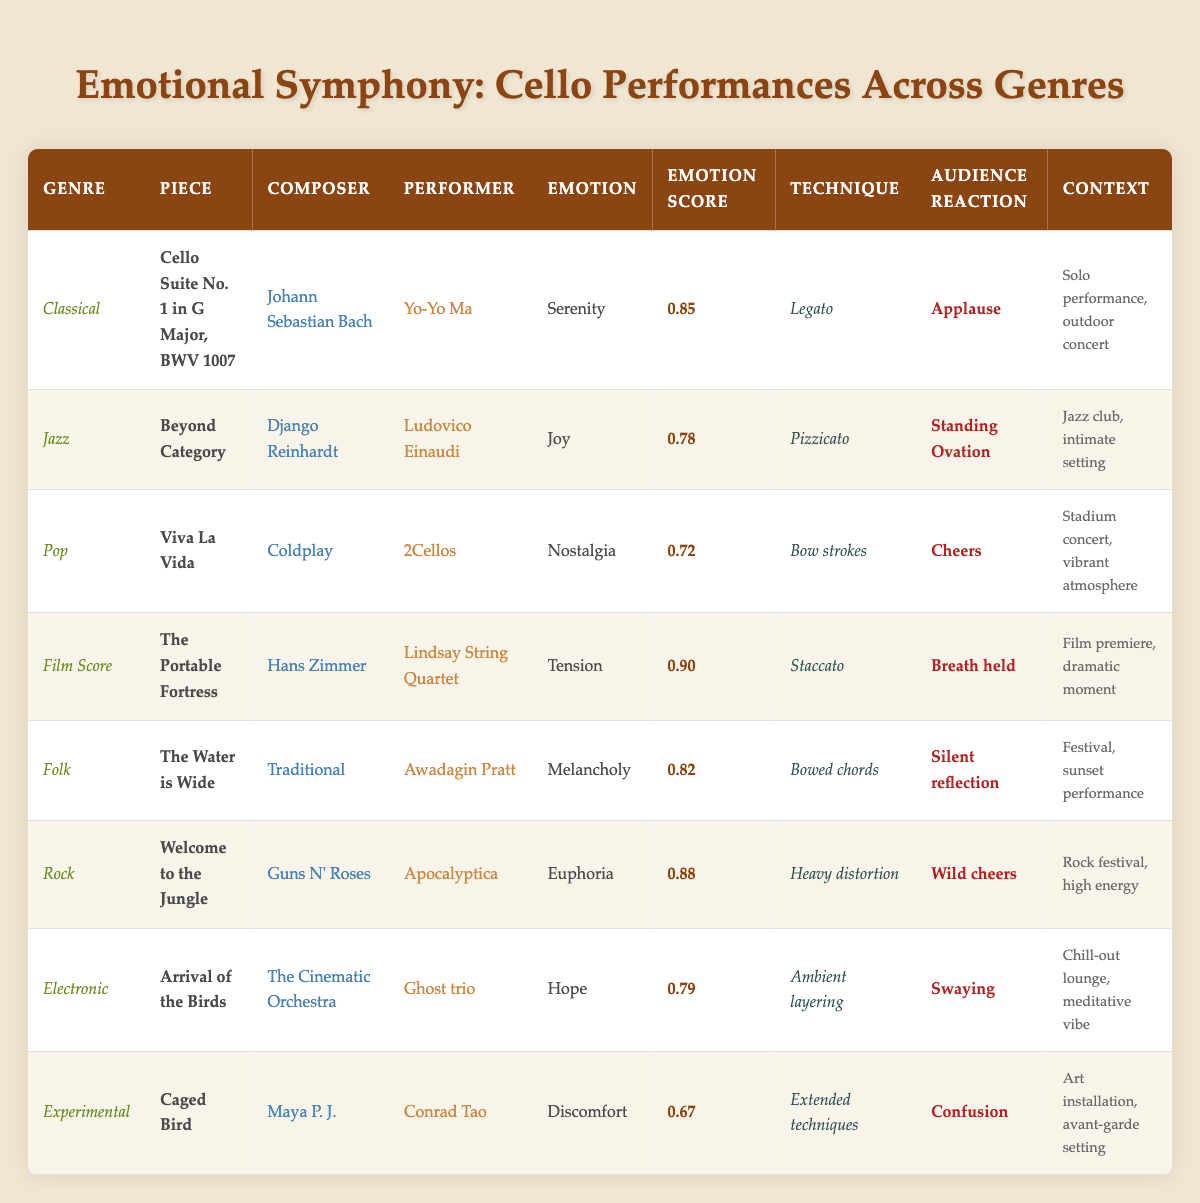What is the emotion associated with the piece "Cello Suite No. 1 in G Major, BWV 1007"? By looking at the table, in the row for "Cello Suite No. 1 in G Major, BWV 1007" under the emotion column, the listed emotion is "Serenity."
Answer: Serenity Who performed "Viva La Vida"? Referring to the row for "Viva La Vida," the performer is identified as "2Cellos."
Answer: 2Cellos Which genre has the highest emotion score? By checking the emotion score column, the highest score is 0.90 corresponding to the "Film Score" genre with the piece "The Portable Fortress."
Answer: Film Score What technique did Ludovico Einaudi use in his jazz performance? In the row for Ludovico Einaudi's performance of "Beyond Category" in the Jazz genre, the technique listed is "Pizzicato."
Answer: Pizzicato Was the audience reaction for Apocalyptica's performance positive? The audience reaction for "Welcome to the Jungle" performed by Apocalyptica shows "Wild cheers," which indicates a positive reaction.
Answer: Yes What emotion is associated with the "Caged Bird," and what is its emotion score? The "Caged Bird" piece is associated with "Discomfort," and its emotion score is 0.67, as listed in the respective columns for that entry.
Answer: Discomfort, 0.67 Calculate the average emotion score for all performances listed. Adding all the emotion scores: (0.85 + 0.78 + 0.72 + 0.90 + 0.82 + 0.88 + 0.79 + 0.67) = 5.70. Then divide by the number of performances (8): 5.70 / 8 = 0.7125 (which can be rounded to 0.71).
Answer: 0.71 Which piece had the lowest emotion score, and how did the audience react? In the table, "Caged Bird" has the lowest emotion score of 0.67; its audience reaction was "Confusion."
Answer: Caged Bird, Confusion Identify the performer with the highest emotion score and the piece they performed. The performer is "Lindsay String Quartet," and the piece is "The Portable Fortress," which has the highest emotion score of 0.90.
Answer: Lindsay String Quartet, The Portable Fortress Is there a genre that features the emotion "Euphoria"? In the table, "Euphoria" is listed as the emotion under the "Rock" genre. Therefore, there is a genre with that emotion.
Answer: Yes 